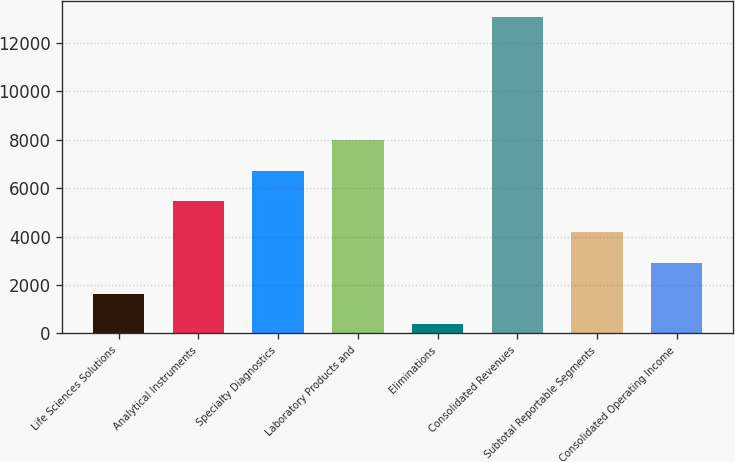Convert chart to OTSL. <chart><loc_0><loc_0><loc_500><loc_500><bar_chart><fcel>Life Sciences Solutions<fcel>Analytical Instruments<fcel>Specialty Diagnostics<fcel>Laboratory Products and<fcel>Eliminations<fcel>Consolidated Revenues<fcel>Subtotal Reportable Segments<fcel>Consolidated Operating Income<nl><fcel>1639.24<fcel>5456.26<fcel>6728.6<fcel>8000.94<fcel>366.9<fcel>13090.3<fcel>4183.92<fcel>2911.58<nl></chart> 